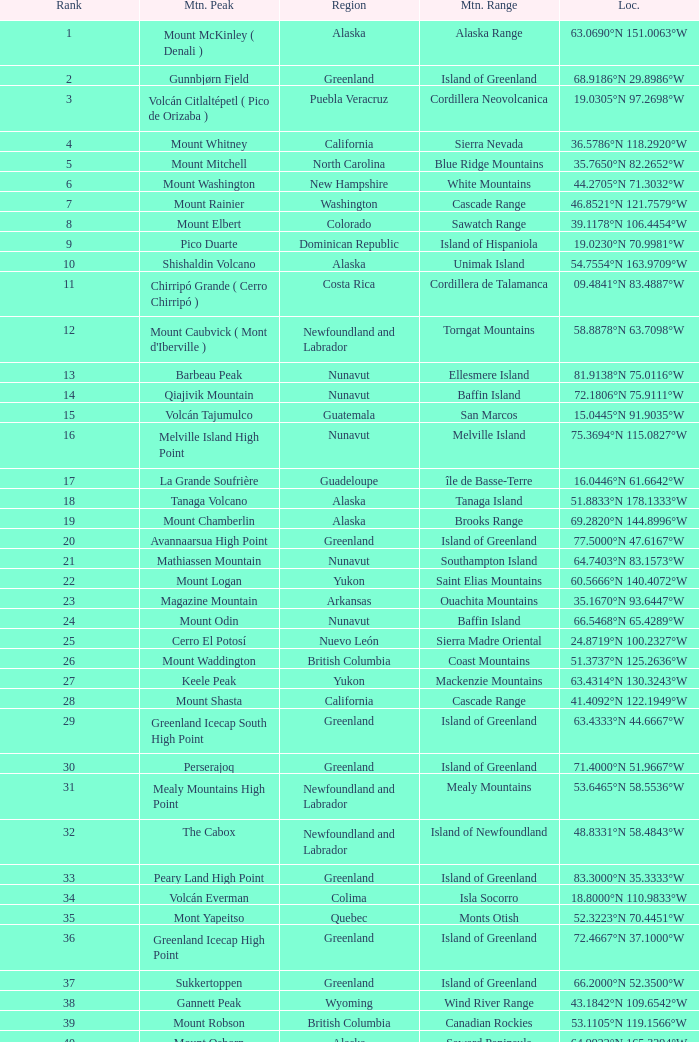Which mountain summit is situated in the baja california area and has coordinates of 2 Isla Cedros High Point. 